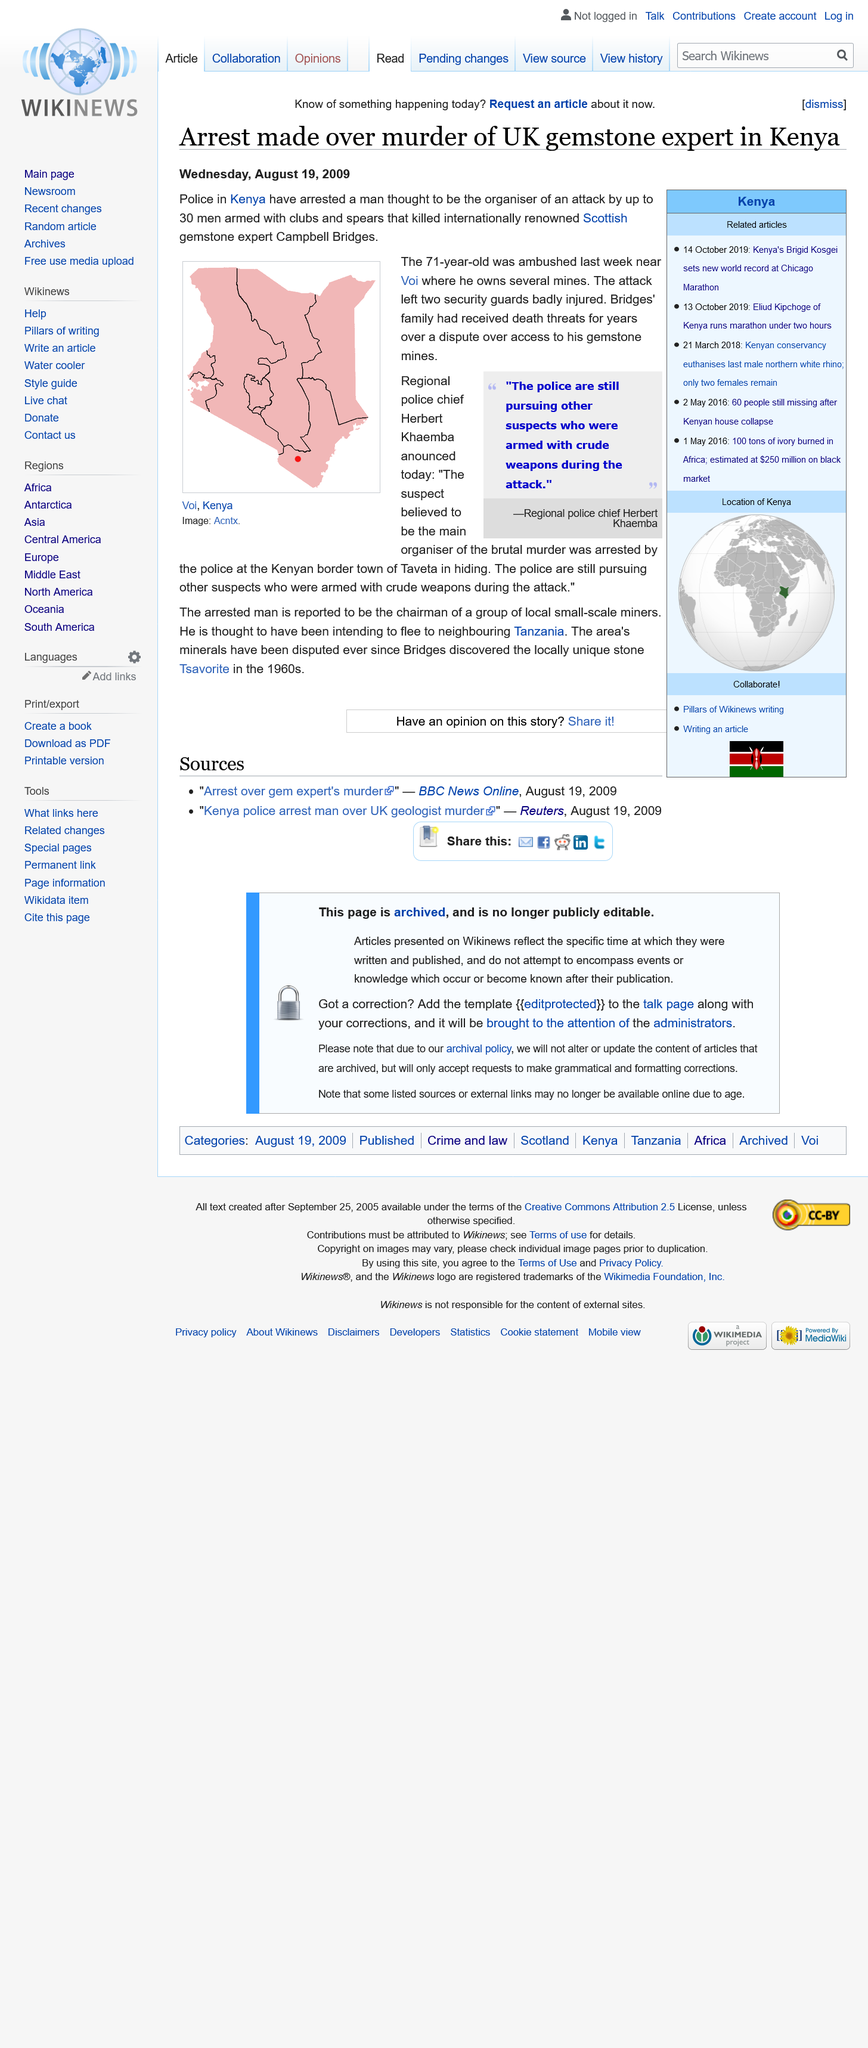Highlight a few significant elements in this photo. The man suspected of killing a renowned gemstone expert in the UK was arrested in Taveta, a town located near Voi in Kenya. Campbell Bridges was Scottish. Campbell Bridges discovered the locally unique stone Tsavorite in the 1960s. 